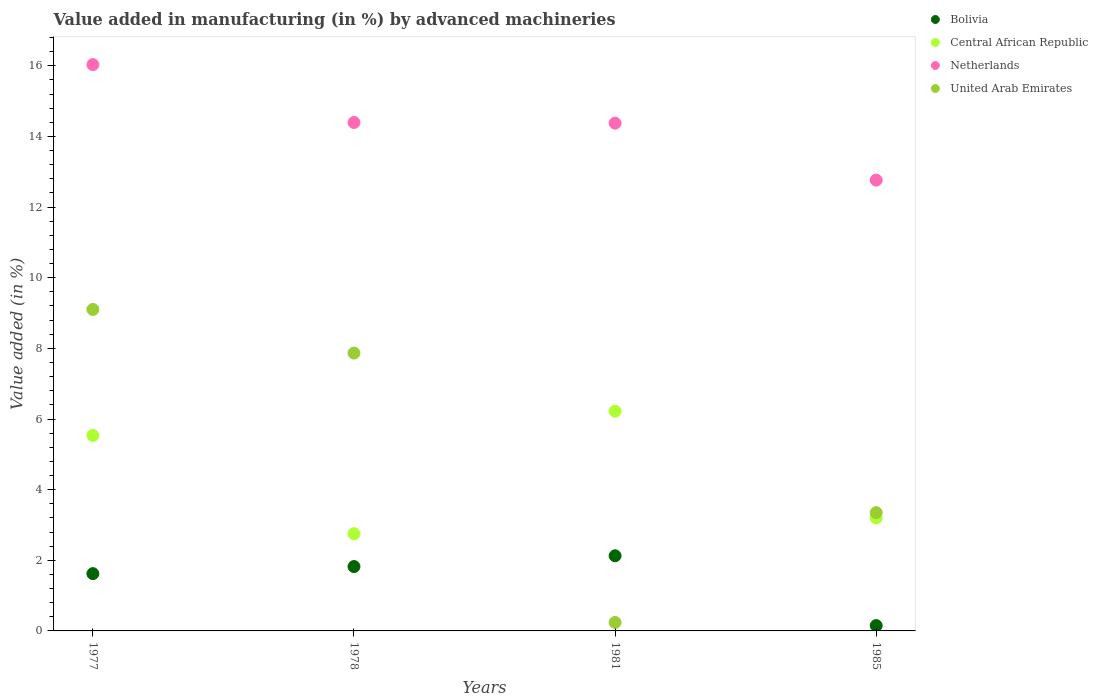Is the number of dotlines equal to the number of legend labels?
Your response must be concise. Yes. What is the percentage of value added in manufacturing by advanced machineries in Bolivia in 1981?
Your answer should be very brief. 2.13. Across all years, what is the maximum percentage of value added in manufacturing by advanced machineries in Bolivia?
Your answer should be very brief. 2.13. Across all years, what is the minimum percentage of value added in manufacturing by advanced machineries in Central African Republic?
Make the answer very short. 2.75. What is the total percentage of value added in manufacturing by advanced machineries in Netherlands in the graph?
Provide a short and direct response. 57.57. What is the difference between the percentage of value added in manufacturing by advanced machineries in Bolivia in 1977 and that in 1985?
Make the answer very short. 1.47. What is the difference between the percentage of value added in manufacturing by advanced machineries in United Arab Emirates in 1985 and the percentage of value added in manufacturing by advanced machineries in Bolivia in 1978?
Provide a succinct answer. 1.53. What is the average percentage of value added in manufacturing by advanced machineries in Netherlands per year?
Provide a succinct answer. 14.39. In the year 1981, what is the difference between the percentage of value added in manufacturing by advanced machineries in Central African Republic and percentage of value added in manufacturing by advanced machineries in Netherlands?
Give a very brief answer. -8.16. In how many years, is the percentage of value added in manufacturing by advanced machineries in Central African Republic greater than 1.6 %?
Provide a succinct answer. 4. What is the ratio of the percentage of value added in manufacturing by advanced machineries in United Arab Emirates in 1977 to that in 1985?
Provide a short and direct response. 2.72. What is the difference between the highest and the second highest percentage of value added in manufacturing by advanced machineries in Bolivia?
Make the answer very short. 0.31. What is the difference between the highest and the lowest percentage of value added in manufacturing by advanced machineries in Bolivia?
Offer a terse response. 1.98. In how many years, is the percentage of value added in manufacturing by advanced machineries in United Arab Emirates greater than the average percentage of value added in manufacturing by advanced machineries in United Arab Emirates taken over all years?
Make the answer very short. 2. Is the sum of the percentage of value added in manufacturing by advanced machineries in Central African Republic in 1978 and 1985 greater than the maximum percentage of value added in manufacturing by advanced machineries in United Arab Emirates across all years?
Keep it short and to the point. No. Is it the case that in every year, the sum of the percentage of value added in manufacturing by advanced machineries in Central African Republic and percentage of value added in manufacturing by advanced machineries in United Arab Emirates  is greater than the percentage of value added in manufacturing by advanced machineries in Bolivia?
Offer a terse response. Yes. Is the percentage of value added in manufacturing by advanced machineries in Central African Republic strictly greater than the percentage of value added in manufacturing by advanced machineries in Bolivia over the years?
Offer a terse response. Yes. How many dotlines are there?
Provide a succinct answer. 4. How many years are there in the graph?
Your answer should be compact. 4. What is the difference between two consecutive major ticks on the Y-axis?
Offer a terse response. 2. Are the values on the major ticks of Y-axis written in scientific E-notation?
Keep it short and to the point. No. Does the graph contain grids?
Offer a terse response. No. Where does the legend appear in the graph?
Your answer should be very brief. Top right. What is the title of the graph?
Give a very brief answer. Value added in manufacturing (in %) by advanced machineries. Does "Tuvalu" appear as one of the legend labels in the graph?
Give a very brief answer. No. What is the label or title of the Y-axis?
Ensure brevity in your answer.  Value added (in %). What is the Value added (in %) of Bolivia in 1977?
Your answer should be compact. 1.62. What is the Value added (in %) of Central African Republic in 1977?
Give a very brief answer. 5.53. What is the Value added (in %) of Netherlands in 1977?
Make the answer very short. 16.03. What is the Value added (in %) in United Arab Emirates in 1977?
Keep it short and to the point. 9.1. What is the Value added (in %) in Bolivia in 1978?
Give a very brief answer. 1.82. What is the Value added (in %) of Central African Republic in 1978?
Give a very brief answer. 2.75. What is the Value added (in %) in Netherlands in 1978?
Your answer should be very brief. 14.4. What is the Value added (in %) of United Arab Emirates in 1978?
Ensure brevity in your answer.  7.87. What is the Value added (in %) of Bolivia in 1981?
Provide a succinct answer. 2.13. What is the Value added (in %) of Central African Republic in 1981?
Keep it short and to the point. 6.22. What is the Value added (in %) of Netherlands in 1981?
Offer a terse response. 14.38. What is the Value added (in %) of United Arab Emirates in 1981?
Your response must be concise. 0.24. What is the Value added (in %) of Bolivia in 1985?
Provide a short and direct response. 0.15. What is the Value added (in %) in Central African Republic in 1985?
Offer a very short reply. 3.2. What is the Value added (in %) in Netherlands in 1985?
Your answer should be compact. 12.76. What is the Value added (in %) of United Arab Emirates in 1985?
Make the answer very short. 3.35. Across all years, what is the maximum Value added (in %) of Bolivia?
Provide a succinct answer. 2.13. Across all years, what is the maximum Value added (in %) of Central African Republic?
Ensure brevity in your answer.  6.22. Across all years, what is the maximum Value added (in %) of Netherlands?
Offer a terse response. 16.03. Across all years, what is the maximum Value added (in %) of United Arab Emirates?
Provide a short and direct response. 9.1. Across all years, what is the minimum Value added (in %) of Bolivia?
Your response must be concise. 0.15. Across all years, what is the minimum Value added (in %) of Central African Republic?
Provide a short and direct response. 2.75. Across all years, what is the minimum Value added (in %) in Netherlands?
Ensure brevity in your answer.  12.76. Across all years, what is the minimum Value added (in %) of United Arab Emirates?
Provide a short and direct response. 0.24. What is the total Value added (in %) of Bolivia in the graph?
Your answer should be very brief. 5.72. What is the total Value added (in %) in Central African Republic in the graph?
Ensure brevity in your answer.  17.71. What is the total Value added (in %) of Netherlands in the graph?
Keep it short and to the point. 57.57. What is the total Value added (in %) in United Arab Emirates in the graph?
Your response must be concise. 20.56. What is the difference between the Value added (in %) of Bolivia in 1977 and that in 1978?
Offer a very short reply. -0.2. What is the difference between the Value added (in %) in Central African Republic in 1977 and that in 1978?
Make the answer very short. 2.78. What is the difference between the Value added (in %) in Netherlands in 1977 and that in 1978?
Ensure brevity in your answer.  1.64. What is the difference between the Value added (in %) of United Arab Emirates in 1977 and that in 1978?
Offer a terse response. 1.23. What is the difference between the Value added (in %) in Bolivia in 1977 and that in 1981?
Your answer should be compact. -0.51. What is the difference between the Value added (in %) of Central African Republic in 1977 and that in 1981?
Provide a succinct answer. -0.69. What is the difference between the Value added (in %) of Netherlands in 1977 and that in 1981?
Make the answer very short. 1.66. What is the difference between the Value added (in %) in United Arab Emirates in 1977 and that in 1981?
Keep it short and to the point. 8.86. What is the difference between the Value added (in %) in Bolivia in 1977 and that in 1985?
Offer a terse response. 1.47. What is the difference between the Value added (in %) in Central African Republic in 1977 and that in 1985?
Offer a very short reply. 2.33. What is the difference between the Value added (in %) of Netherlands in 1977 and that in 1985?
Offer a terse response. 3.27. What is the difference between the Value added (in %) of United Arab Emirates in 1977 and that in 1985?
Give a very brief answer. 5.75. What is the difference between the Value added (in %) in Bolivia in 1978 and that in 1981?
Your answer should be very brief. -0.31. What is the difference between the Value added (in %) in Central African Republic in 1978 and that in 1981?
Offer a terse response. -3.47. What is the difference between the Value added (in %) of Netherlands in 1978 and that in 1981?
Keep it short and to the point. 0.02. What is the difference between the Value added (in %) of United Arab Emirates in 1978 and that in 1981?
Make the answer very short. 7.63. What is the difference between the Value added (in %) in Bolivia in 1978 and that in 1985?
Your answer should be very brief. 1.67. What is the difference between the Value added (in %) in Central African Republic in 1978 and that in 1985?
Give a very brief answer. -0.45. What is the difference between the Value added (in %) of Netherlands in 1978 and that in 1985?
Provide a short and direct response. 1.63. What is the difference between the Value added (in %) of United Arab Emirates in 1978 and that in 1985?
Make the answer very short. 4.52. What is the difference between the Value added (in %) in Bolivia in 1981 and that in 1985?
Your response must be concise. 1.98. What is the difference between the Value added (in %) of Central African Republic in 1981 and that in 1985?
Your answer should be very brief. 3.02. What is the difference between the Value added (in %) in Netherlands in 1981 and that in 1985?
Offer a very short reply. 1.61. What is the difference between the Value added (in %) of United Arab Emirates in 1981 and that in 1985?
Your response must be concise. -3.11. What is the difference between the Value added (in %) of Bolivia in 1977 and the Value added (in %) of Central African Republic in 1978?
Provide a succinct answer. -1.13. What is the difference between the Value added (in %) of Bolivia in 1977 and the Value added (in %) of Netherlands in 1978?
Your answer should be very brief. -12.77. What is the difference between the Value added (in %) of Bolivia in 1977 and the Value added (in %) of United Arab Emirates in 1978?
Give a very brief answer. -6.25. What is the difference between the Value added (in %) of Central African Republic in 1977 and the Value added (in %) of Netherlands in 1978?
Make the answer very short. -8.86. What is the difference between the Value added (in %) in Central African Republic in 1977 and the Value added (in %) in United Arab Emirates in 1978?
Offer a very short reply. -2.33. What is the difference between the Value added (in %) in Netherlands in 1977 and the Value added (in %) in United Arab Emirates in 1978?
Your answer should be compact. 8.17. What is the difference between the Value added (in %) of Bolivia in 1977 and the Value added (in %) of Central African Republic in 1981?
Provide a succinct answer. -4.6. What is the difference between the Value added (in %) of Bolivia in 1977 and the Value added (in %) of Netherlands in 1981?
Offer a very short reply. -12.75. What is the difference between the Value added (in %) in Bolivia in 1977 and the Value added (in %) in United Arab Emirates in 1981?
Keep it short and to the point. 1.38. What is the difference between the Value added (in %) in Central African Republic in 1977 and the Value added (in %) in Netherlands in 1981?
Your response must be concise. -8.84. What is the difference between the Value added (in %) of Central African Republic in 1977 and the Value added (in %) of United Arab Emirates in 1981?
Your response must be concise. 5.29. What is the difference between the Value added (in %) of Netherlands in 1977 and the Value added (in %) of United Arab Emirates in 1981?
Your answer should be compact. 15.79. What is the difference between the Value added (in %) of Bolivia in 1977 and the Value added (in %) of Central African Republic in 1985?
Your response must be concise. -1.58. What is the difference between the Value added (in %) in Bolivia in 1977 and the Value added (in %) in Netherlands in 1985?
Make the answer very short. -11.14. What is the difference between the Value added (in %) in Bolivia in 1977 and the Value added (in %) in United Arab Emirates in 1985?
Your answer should be compact. -1.73. What is the difference between the Value added (in %) of Central African Republic in 1977 and the Value added (in %) of Netherlands in 1985?
Your answer should be very brief. -7.23. What is the difference between the Value added (in %) in Central African Republic in 1977 and the Value added (in %) in United Arab Emirates in 1985?
Provide a succinct answer. 2.19. What is the difference between the Value added (in %) of Netherlands in 1977 and the Value added (in %) of United Arab Emirates in 1985?
Keep it short and to the point. 12.68. What is the difference between the Value added (in %) of Bolivia in 1978 and the Value added (in %) of Central African Republic in 1981?
Make the answer very short. -4.4. What is the difference between the Value added (in %) of Bolivia in 1978 and the Value added (in %) of Netherlands in 1981?
Your response must be concise. -12.55. What is the difference between the Value added (in %) in Bolivia in 1978 and the Value added (in %) in United Arab Emirates in 1981?
Keep it short and to the point. 1.58. What is the difference between the Value added (in %) in Central African Republic in 1978 and the Value added (in %) in Netherlands in 1981?
Offer a very short reply. -11.62. What is the difference between the Value added (in %) in Central African Republic in 1978 and the Value added (in %) in United Arab Emirates in 1981?
Your response must be concise. 2.51. What is the difference between the Value added (in %) of Netherlands in 1978 and the Value added (in %) of United Arab Emirates in 1981?
Offer a very short reply. 14.16. What is the difference between the Value added (in %) in Bolivia in 1978 and the Value added (in %) in Central African Republic in 1985?
Keep it short and to the point. -1.38. What is the difference between the Value added (in %) in Bolivia in 1978 and the Value added (in %) in Netherlands in 1985?
Provide a succinct answer. -10.94. What is the difference between the Value added (in %) of Bolivia in 1978 and the Value added (in %) of United Arab Emirates in 1985?
Offer a very short reply. -1.53. What is the difference between the Value added (in %) in Central African Republic in 1978 and the Value added (in %) in Netherlands in 1985?
Give a very brief answer. -10.01. What is the difference between the Value added (in %) in Central African Republic in 1978 and the Value added (in %) in United Arab Emirates in 1985?
Keep it short and to the point. -0.6. What is the difference between the Value added (in %) of Netherlands in 1978 and the Value added (in %) of United Arab Emirates in 1985?
Offer a very short reply. 11.05. What is the difference between the Value added (in %) in Bolivia in 1981 and the Value added (in %) in Central African Republic in 1985?
Offer a very short reply. -1.07. What is the difference between the Value added (in %) of Bolivia in 1981 and the Value added (in %) of Netherlands in 1985?
Give a very brief answer. -10.64. What is the difference between the Value added (in %) in Bolivia in 1981 and the Value added (in %) in United Arab Emirates in 1985?
Your response must be concise. -1.22. What is the difference between the Value added (in %) in Central African Republic in 1981 and the Value added (in %) in Netherlands in 1985?
Make the answer very short. -6.54. What is the difference between the Value added (in %) of Central African Republic in 1981 and the Value added (in %) of United Arab Emirates in 1985?
Give a very brief answer. 2.87. What is the difference between the Value added (in %) in Netherlands in 1981 and the Value added (in %) in United Arab Emirates in 1985?
Your answer should be compact. 11.03. What is the average Value added (in %) in Bolivia per year?
Provide a short and direct response. 1.43. What is the average Value added (in %) of Central African Republic per year?
Give a very brief answer. 4.43. What is the average Value added (in %) in Netherlands per year?
Your response must be concise. 14.39. What is the average Value added (in %) in United Arab Emirates per year?
Provide a short and direct response. 5.14. In the year 1977, what is the difference between the Value added (in %) of Bolivia and Value added (in %) of Central African Republic?
Your answer should be very brief. -3.91. In the year 1977, what is the difference between the Value added (in %) in Bolivia and Value added (in %) in Netherlands?
Provide a succinct answer. -14.41. In the year 1977, what is the difference between the Value added (in %) of Bolivia and Value added (in %) of United Arab Emirates?
Keep it short and to the point. -7.48. In the year 1977, what is the difference between the Value added (in %) in Central African Republic and Value added (in %) in Netherlands?
Your answer should be compact. -10.5. In the year 1977, what is the difference between the Value added (in %) in Central African Republic and Value added (in %) in United Arab Emirates?
Offer a terse response. -3.57. In the year 1977, what is the difference between the Value added (in %) of Netherlands and Value added (in %) of United Arab Emirates?
Your answer should be very brief. 6.93. In the year 1978, what is the difference between the Value added (in %) of Bolivia and Value added (in %) of Central African Republic?
Your response must be concise. -0.93. In the year 1978, what is the difference between the Value added (in %) of Bolivia and Value added (in %) of Netherlands?
Keep it short and to the point. -12.57. In the year 1978, what is the difference between the Value added (in %) in Bolivia and Value added (in %) in United Arab Emirates?
Offer a very short reply. -6.05. In the year 1978, what is the difference between the Value added (in %) of Central African Republic and Value added (in %) of Netherlands?
Offer a terse response. -11.64. In the year 1978, what is the difference between the Value added (in %) in Central African Republic and Value added (in %) in United Arab Emirates?
Your answer should be very brief. -5.11. In the year 1978, what is the difference between the Value added (in %) of Netherlands and Value added (in %) of United Arab Emirates?
Provide a short and direct response. 6.53. In the year 1981, what is the difference between the Value added (in %) in Bolivia and Value added (in %) in Central African Republic?
Keep it short and to the point. -4.09. In the year 1981, what is the difference between the Value added (in %) of Bolivia and Value added (in %) of Netherlands?
Your response must be concise. -12.25. In the year 1981, what is the difference between the Value added (in %) of Bolivia and Value added (in %) of United Arab Emirates?
Make the answer very short. 1.89. In the year 1981, what is the difference between the Value added (in %) in Central African Republic and Value added (in %) in Netherlands?
Provide a succinct answer. -8.16. In the year 1981, what is the difference between the Value added (in %) in Central African Republic and Value added (in %) in United Arab Emirates?
Ensure brevity in your answer.  5.98. In the year 1981, what is the difference between the Value added (in %) of Netherlands and Value added (in %) of United Arab Emirates?
Keep it short and to the point. 14.14. In the year 1985, what is the difference between the Value added (in %) of Bolivia and Value added (in %) of Central African Republic?
Provide a short and direct response. -3.05. In the year 1985, what is the difference between the Value added (in %) of Bolivia and Value added (in %) of Netherlands?
Offer a very short reply. -12.61. In the year 1985, what is the difference between the Value added (in %) in Bolivia and Value added (in %) in United Arab Emirates?
Provide a succinct answer. -3.2. In the year 1985, what is the difference between the Value added (in %) in Central African Republic and Value added (in %) in Netherlands?
Your answer should be compact. -9.56. In the year 1985, what is the difference between the Value added (in %) in Central African Republic and Value added (in %) in United Arab Emirates?
Offer a terse response. -0.15. In the year 1985, what is the difference between the Value added (in %) of Netherlands and Value added (in %) of United Arab Emirates?
Offer a terse response. 9.41. What is the ratio of the Value added (in %) in Bolivia in 1977 to that in 1978?
Provide a short and direct response. 0.89. What is the ratio of the Value added (in %) of Central African Republic in 1977 to that in 1978?
Make the answer very short. 2.01. What is the ratio of the Value added (in %) in Netherlands in 1977 to that in 1978?
Offer a very short reply. 1.11. What is the ratio of the Value added (in %) in United Arab Emirates in 1977 to that in 1978?
Give a very brief answer. 1.16. What is the ratio of the Value added (in %) in Bolivia in 1977 to that in 1981?
Make the answer very short. 0.76. What is the ratio of the Value added (in %) of Central African Republic in 1977 to that in 1981?
Your response must be concise. 0.89. What is the ratio of the Value added (in %) in Netherlands in 1977 to that in 1981?
Offer a terse response. 1.12. What is the ratio of the Value added (in %) of United Arab Emirates in 1977 to that in 1981?
Offer a terse response. 37.96. What is the ratio of the Value added (in %) of Bolivia in 1977 to that in 1985?
Ensure brevity in your answer.  10.75. What is the ratio of the Value added (in %) of Central African Republic in 1977 to that in 1985?
Keep it short and to the point. 1.73. What is the ratio of the Value added (in %) in Netherlands in 1977 to that in 1985?
Provide a short and direct response. 1.26. What is the ratio of the Value added (in %) of United Arab Emirates in 1977 to that in 1985?
Provide a short and direct response. 2.72. What is the ratio of the Value added (in %) of Bolivia in 1978 to that in 1981?
Your answer should be very brief. 0.86. What is the ratio of the Value added (in %) of Central African Republic in 1978 to that in 1981?
Give a very brief answer. 0.44. What is the ratio of the Value added (in %) of Netherlands in 1978 to that in 1981?
Offer a terse response. 1. What is the ratio of the Value added (in %) of United Arab Emirates in 1978 to that in 1981?
Provide a short and direct response. 32.81. What is the ratio of the Value added (in %) in Bolivia in 1978 to that in 1985?
Provide a succinct answer. 12.08. What is the ratio of the Value added (in %) in Central African Republic in 1978 to that in 1985?
Give a very brief answer. 0.86. What is the ratio of the Value added (in %) of Netherlands in 1978 to that in 1985?
Keep it short and to the point. 1.13. What is the ratio of the Value added (in %) in United Arab Emirates in 1978 to that in 1985?
Provide a short and direct response. 2.35. What is the ratio of the Value added (in %) in Bolivia in 1981 to that in 1985?
Make the answer very short. 14.1. What is the ratio of the Value added (in %) of Central African Republic in 1981 to that in 1985?
Provide a succinct answer. 1.94. What is the ratio of the Value added (in %) in Netherlands in 1981 to that in 1985?
Keep it short and to the point. 1.13. What is the ratio of the Value added (in %) of United Arab Emirates in 1981 to that in 1985?
Your answer should be compact. 0.07. What is the difference between the highest and the second highest Value added (in %) of Bolivia?
Ensure brevity in your answer.  0.31. What is the difference between the highest and the second highest Value added (in %) of Central African Republic?
Provide a short and direct response. 0.69. What is the difference between the highest and the second highest Value added (in %) of Netherlands?
Provide a succinct answer. 1.64. What is the difference between the highest and the second highest Value added (in %) in United Arab Emirates?
Make the answer very short. 1.23. What is the difference between the highest and the lowest Value added (in %) in Bolivia?
Keep it short and to the point. 1.98. What is the difference between the highest and the lowest Value added (in %) of Central African Republic?
Your answer should be very brief. 3.47. What is the difference between the highest and the lowest Value added (in %) in Netherlands?
Offer a terse response. 3.27. What is the difference between the highest and the lowest Value added (in %) in United Arab Emirates?
Offer a very short reply. 8.86. 